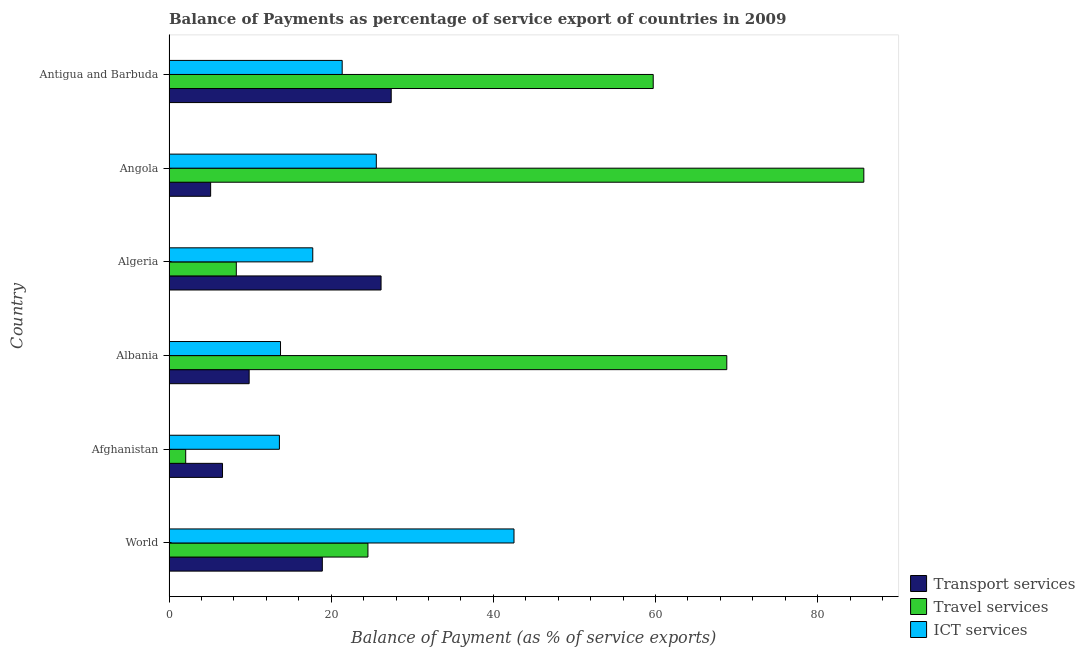How many different coloured bars are there?
Your answer should be very brief. 3. How many groups of bars are there?
Provide a succinct answer. 6. Are the number of bars per tick equal to the number of legend labels?
Give a very brief answer. Yes. Are the number of bars on each tick of the Y-axis equal?
Your answer should be very brief. Yes. How many bars are there on the 1st tick from the top?
Provide a succinct answer. 3. What is the balance of payment of travel services in World?
Provide a succinct answer. 24.54. Across all countries, what is the maximum balance of payment of transport services?
Your response must be concise. 27.41. Across all countries, what is the minimum balance of payment of transport services?
Offer a terse response. 5.14. In which country was the balance of payment of ict services maximum?
Ensure brevity in your answer.  World. In which country was the balance of payment of ict services minimum?
Give a very brief answer. Afghanistan. What is the total balance of payment of travel services in the graph?
Give a very brief answer. 249.12. What is the difference between the balance of payment of transport services in Albania and that in Algeria?
Give a very brief answer. -16.27. What is the difference between the balance of payment of transport services in Albania and the balance of payment of ict services in Antigua and Barbuda?
Offer a terse response. -11.47. What is the average balance of payment of ict services per country?
Keep it short and to the point. 22.43. What is the difference between the balance of payment of ict services and balance of payment of travel services in Angola?
Offer a terse response. -60.13. In how many countries, is the balance of payment of ict services greater than 60 %?
Provide a succinct answer. 0. What is the difference between the highest and the second highest balance of payment of transport services?
Your answer should be compact. 1.25. What is the difference between the highest and the lowest balance of payment of ict services?
Make the answer very short. 28.93. What does the 1st bar from the top in World represents?
Make the answer very short. ICT services. What does the 1st bar from the bottom in World represents?
Give a very brief answer. Transport services. Is it the case that in every country, the sum of the balance of payment of transport services and balance of payment of travel services is greater than the balance of payment of ict services?
Your response must be concise. No. How many bars are there?
Offer a terse response. 18. Are all the bars in the graph horizontal?
Provide a short and direct response. Yes. How many countries are there in the graph?
Keep it short and to the point. 6. What is the difference between two consecutive major ticks on the X-axis?
Make the answer very short. 20. Does the graph contain any zero values?
Ensure brevity in your answer.  No. Where does the legend appear in the graph?
Ensure brevity in your answer.  Bottom right. What is the title of the graph?
Offer a very short reply. Balance of Payments as percentage of service export of countries in 2009. Does "Unemployment benefits" appear as one of the legend labels in the graph?
Keep it short and to the point. No. What is the label or title of the X-axis?
Your response must be concise. Balance of Payment (as % of service exports). What is the Balance of Payment (as % of service exports) of Transport services in World?
Offer a terse response. 18.91. What is the Balance of Payment (as % of service exports) of Travel services in World?
Offer a very short reply. 24.54. What is the Balance of Payment (as % of service exports) in ICT services in World?
Make the answer very short. 42.55. What is the Balance of Payment (as % of service exports) in Transport services in Afghanistan?
Offer a terse response. 6.6. What is the Balance of Payment (as % of service exports) of Travel services in Afghanistan?
Make the answer very short. 2.06. What is the Balance of Payment (as % of service exports) in ICT services in Afghanistan?
Offer a terse response. 13.62. What is the Balance of Payment (as % of service exports) in Transport services in Albania?
Give a very brief answer. 9.89. What is the Balance of Payment (as % of service exports) of Travel services in Albania?
Give a very brief answer. 68.8. What is the Balance of Payment (as % of service exports) of ICT services in Albania?
Make the answer very short. 13.75. What is the Balance of Payment (as % of service exports) of Transport services in Algeria?
Offer a terse response. 26.15. What is the Balance of Payment (as % of service exports) in Travel services in Algeria?
Your response must be concise. 8.3. What is the Balance of Payment (as % of service exports) in ICT services in Algeria?
Give a very brief answer. 17.73. What is the Balance of Payment (as % of service exports) in Transport services in Angola?
Your answer should be compact. 5.14. What is the Balance of Payment (as % of service exports) of Travel services in Angola?
Your response must be concise. 85.7. What is the Balance of Payment (as % of service exports) of ICT services in Angola?
Your answer should be compact. 25.57. What is the Balance of Payment (as % of service exports) in Transport services in Antigua and Barbuda?
Offer a very short reply. 27.41. What is the Balance of Payment (as % of service exports) of Travel services in Antigua and Barbuda?
Your answer should be very brief. 59.72. What is the Balance of Payment (as % of service exports) of ICT services in Antigua and Barbuda?
Give a very brief answer. 21.36. Across all countries, what is the maximum Balance of Payment (as % of service exports) of Transport services?
Your response must be concise. 27.41. Across all countries, what is the maximum Balance of Payment (as % of service exports) of Travel services?
Offer a very short reply. 85.7. Across all countries, what is the maximum Balance of Payment (as % of service exports) of ICT services?
Your answer should be very brief. 42.55. Across all countries, what is the minimum Balance of Payment (as % of service exports) in Transport services?
Offer a terse response. 5.14. Across all countries, what is the minimum Balance of Payment (as % of service exports) of Travel services?
Make the answer very short. 2.06. Across all countries, what is the minimum Balance of Payment (as % of service exports) of ICT services?
Ensure brevity in your answer.  13.62. What is the total Balance of Payment (as % of service exports) of Transport services in the graph?
Offer a very short reply. 94.1. What is the total Balance of Payment (as % of service exports) in Travel services in the graph?
Make the answer very short. 249.12. What is the total Balance of Payment (as % of service exports) of ICT services in the graph?
Offer a very short reply. 134.58. What is the difference between the Balance of Payment (as % of service exports) of Transport services in World and that in Afghanistan?
Give a very brief answer. 12.31. What is the difference between the Balance of Payment (as % of service exports) in Travel services in World and that in Afghanistan?
Offer a terse response. 22.48. What is the difference between the Balance of Payment (as % of service exports) in ICT services in World and that in Afghanistan?
Provide a short and direct response. 28.93. What is the difference between the Balance of Payment (as % of service exports) of Transport services in World and that in Albania?
Give a very brief answer. 9.02. What is the difference between the Balance of Payment (as % of service exports) in Travel services in World and that in Albania?
Your response must be concise. -44.26. What is the difference between the Balance of Payment (as % of service exports) of ICT services in World and that in Albania?
Your answer should be very brief. 28.8. What is the difference between the Balance of Payment (as % of service exports) in Transport services in World and that in Algeria?
Keep it short and to the point. -7.24. What is the difference between the Balance of Payment (as % of service exports) of Travel services in World and that in Algeria?
Your answer should be very brief. 16.24. What is the difference between the Balance of Payment (as % of service exports) of ICT services in World and that in Algeria?
Ensure brevity in your answer.  24.82. What is the difference between the Balance of Payment (as % of service exports) in Transport services in World and that in Angola?
Keep it short and to the point. 13.78. What is the difference between the Balance of Payment (as % of service exports) in Travel services in World and that in Angola?
Your answer should be very brief. -61.16. What is the difference between the Balance of Payment (as % of service exports) in ICT services in World and that in Angola?
Provide a short and direct response. 16.98. What is the difference between the Balance of Payment (as % of service exports) of Transport services in World and that in Antigua and Barbuda?
Your answer should be compact. -8.5. What is the difference between the Balance of Payment (as % of service exports) of Travel services in World and that in Antigua and Barbuda?
Your answer should be very brief. -35.19. What is the difference between the Balance of Payment (as % of service exports) in ICT services in World and that in Antigua and Barbuda?
Provide a short and direct response. 21.19. What is the difference between the Balance of Payment (as % of service exports) of Transport services in Afghanistan and that in Albania?
Keep it short and to the point. -3.29. What is the difference between the Balance of Payment (as % of service exports) in Travel services in Afghanistan and that in Albania?
Provide a succinct answer. -66.74. What is the difference between the Balance of Payment (as % of service exports) of ICT services in Afghanistan and that in Albania?
Offer a very short reply. -0.14. What is the difference between the Balance of Payment (as % of service exports) of Transport services in Afghanistan and that in Algeria?
Make the answer very short. -19.55. What is the difference between the Balance of Payment (as % of service exports) of Travel services in Afghanistan and that in Algeria?
Make the answer very short. -6.24. What is the difference between the Balance of Payment (as % of service exports) of ICT services in Afghanistan and that in Algeria?
Offer a very short reply. -4.12. What is the difference between the Balance of Payment (as % of service exports) in Transport services in Afghanistan and that in Angola?
Provide a succinct answer. 1.47. What is the difference between the Balance of Payment (as % of service exports) in Travel services in Afghanistan and that in Angola?
Give a very brief answer. -83.64. What is the difference between the Balance of Payment (as % of service exports) in ICT services in Afghanistan and that in Angola?
Make the answer very short. -11.95. What is the difference between the Balance of Payment (as % of service exports) in Transport services in Afghanistan and that in Antigua and Barbuda?
Give a very brief answer. -20.81. What is the difference between the Balance of Payment (as % of service exports) in Travel services in Afghanistan and that in Antigua and Barbuda?
Your answer should be compact. -57.66. What is the difference between the Balance of Payment (as % of service exports) of ICT services in Afghanistan and that in Antigua and Barbuda?
Make the answer very short. -7.74. What is the difference between the Balance of Payment (as % of service exports) of Transport services in Albania and that in Algeria?
Your answer should be compact. -16.27. What is the difference between the Balance of Payment (as % of service exports) of Travel services in Albania and that in Algeria?
Keep it short and to the point. 60.5. What is the difference between the Balance of Payment (as % of service exports) of ICT services in Albania and that in Algeria?
Your answer should be very brief. -3.98. What is the difference between the Balance of Payment (as % of service exports) in Transport services in Albania and that in Angola?
Provide a succinct answer. 4.75. What is the difference between the Balance of Payment (as % of service exports) of Travel services in Albania and that in Angola?
Make the answer very short. -16.9. What is the difference between the Balance of Payment (as % of service exports) of ICT services in Albania and that in Angola?
Provide a short and direct response. -11.82. What is the difference between the Balance of Payment (as % of service exports) of Transport services in Albania and that in Antigua and Barbuda?
Offer a terse response. -17.52. What is the difference between the Balance of Payment (as % of service exports) of Travel services in Albania and that in Antigua and Barbuda?
Provide a succinct answer. 9.08. What is the difference between the Balance of Payment (as % of service exports) of ICT services in Albania and that in Antigua and Barbuda?
Your answer should be compact. -7.61. What is the difference between the Balance of Payment (as % of service exports) in Transport services in Algeria and that in Angola?
Your answer should be very brief. 21.02. What is the difference between the Balance of Payment (as % of service exports) of Travel services in Algeria and that in Angola?
Your response must be concise. -77.4. What is the difference between the Balance of Payment (as % of service exports) in ICT services in Algeria and that in Angola?
Provide a succinct answer. -7.84. What is the difference between the Balance of Payment (as % of service exports) of Transport services in Algeria and that in Antigua and Barbuda?
Provide a short and direct response. -1.25. What is the difference between the Balance of Payment (as % of service exports) in Travel services in Algeria and that in Antigua and Barbuda?
Make the answer very short. -51.42. What is the difference between the Balance of Payment (as % of service exports) in ICT services in Algeria and that in Antigua and Barbuda?
Your response must be concise. -3.63. What is the difference between the Balance of Payment (as % of service exports) in Transport services in Angola and that in Antigua and Barbuda?
Provide a short and direct response. -22.27. What is the difference between the Balance of Payment (as % of service exports) of Travel services in Angola and that in Antigua and Barbuda?
Your answer should be compact. 25.98. What is the difference between the Balance of Payment (as % of service exports) of ICT services in Angola and that in Antigua and Barbuda?
Keep it short and to the point. 4.21. What is the difference between the Balance of Payment (as % of service exports) of Transport services in World and the Balance of Payment (as % of service exports) of Travel services in Afghanistan?
Ensure brevity in your answer.  16.85. What is the difference between the Balance of Payment (as % of service exports) of Transport services in World and the Balance of Payment (as % of service exports) of ICT services in Afghanistan?
Offer a terse response. 5.29. What is the difference between the Balance of Payment (as % of service exports) of Travel services in World and the Balance of Payment (as % of service exports) of ICT services in Afghanistan?
Offer a very short reply. 10.92. What is the difference between the Balance of Payment (as % of service exports) of Transport services in World and the Balance of Payment (as % of service exports) of Travel services in Albania?
Offer a terse response. -49.89. What is the difference between the Balance of Payment (as % of service exports) of Transport services in World and the Balance of Payment (as % of service exports) of ICT services in Albania?
Ensure brevity in your answer.  5.16. What is the difference between the Balance of Payment (as % of service exports) of Travel services in World and the Balance of Payment (as % of service exports) of ICT services in Albania?
Provide a succinct answer. 10.78. What is the difference between the Balance of Payment (as % of service exports) in Transport services in World and the Balance of Payment (as % of service exports) in Travel services in Algeria?
Provide a succinct answer. 10.61. What is the difference between the Balance of Payment (as % of service exports) of Transport services in World and the Balance of Payment (as % of service exports) of ICT services in Algeria?
Ensure brevity in your answer.  1.18. What is the difference between the Balance of Payment (as % of service exports) of Travel services in World and the Balance of Payment (as % of service exports) of ICT services in Algeria?
Ensure brevity in your answer.  6.8. What is the difference between the Balance of Payment (as % of service exports) of Transport services in World and the Balance of Payment (as % of service exports) of Travel services in Angola?
Your answer should be compact. -66.79. What is the difference between the Balance of Payment (as % of service exports) of Transport services in World and the Balance of Payment (as % of service exports) of ICT services in Angola?
Ensure brevity in your answer.  -6.66. What is the difference between the Balance of Payment (as % of service exports) in Travel services in World and the Balance of Payment (as % of service exports) in ICT services in Angola?
Make the answer very short. -1.03. What is the difference between the Balance of Payment (as % of service exports) in Transport services in World and the Balance of Payment (as % of service exports) in Travel services in Antigua and Barbuda?
Offer a very short reply. -40.81. What is the difference between the Balance of Payment (as % of service exports) of Transport services in World and the Balance of Payment (as % of service exports) of ICT services in Antigua and Barbuda?
Make the answer very short. -2.45. What is the difference between the Balance of Payment (as % of service exports) of Travel services in World and the Balance of Payment (as % of service exports) of ICT services in Antigua and Barbuda?
Provide a succinct answer. 3.18. What is the difference between the Balance of Payment (as % of service exports) of Transport services in Afghanistan and the Balance of Payment (as % of service exports) of Travel services in Albania?
Provide a succinct answer. -62.2. What is the difference between the Balance of Payment (as % of service exports) of Transport services in Afghanistan and the Balance of Payment (as % of service exports) of ICT services in Albania?
Your answer should be compact. -7.15. What is the difference between the Balance of Payment (as % of service exports) of Travel services in Afghanistan and the Balance of Payment (as % of service exports) of ICT services in Albania?
Give a very brief answer. -11.69. What is the difference between the Balance of Payment (as % of service exports) in Transport services in Afghanistan and the Balance of Payment (as % of service exports) in Travel services in Algeria?
Ensure brevity in your answer.  -1.7. What is the difference between the Balance of Payment (as % of service exports) of Transport services in Afghanistan and the Balance of Payment (as % of service exports) of ICT services in Algeria?
Offer a very short reply. -11.13. What is the difference between the Balance of Payment (as % of service exports) in Travel services in Afghanistan and the Balance of Payment (as % of service exports) in ICT services in Algeria?
Give a very brief answer. -15.67. What is the difference between the Balance of Payment (as % of service exports) in Transport services in Afghanistan and the Balance of Payment (as % of service exports) in Travel services in Angola?
Ensure brevity in your answer.  -79.1. What is the difference between the Balance of Payment (as % of service exports) of Transport services in Afghanistan and the Balance of Payment (as % of service exports) of ICT services in Angola?
Give a very brief answer. -18.97. What is the difference between the Balance of Payment (as % of service exports) in Travel services in Afghanistan and the Balance of Payment (as % of service exports) in ICT services in Angola?
Offer a very short reply. -23.51. What is the difference between the Balance of Payment (as % of service exports) in Transport services in Afghanistan and the Balance of Payment (as % of service exports) in Travel services in Antigua and Barbuda?
Offer a very short reply. -53.12. What is the difference between the Balance of Payment (as % of service exports) in Transport services in Afghanistan and the Balance of Payment (as % of service exports) in ICT services in Antigua and Barbuda?
Your answer should be compact. -14.76. What is the difference between the Balance of Payment (as % of service exports) in Travel services in Afghanistan and the Balance of Payment (as % of service exports) in ICT services in Antigua and Barbuda?
Offer a very short reply. -19.3. What is the difference between the Balance of Payment (as % of service exports) of Transport services in Albania and the Balance of Payment (as % of service exports) of Travel services in Algeria?
Provide a succinct answer. 1.59. What is the difference between the Balance of Payment (as % of service exports) of Transport services in Albania and the Balance of Payment (as % of service exports) of ICT services in Algeria?
Keep it short and to the point. -7.85. What is the difference between the Balance of Payment (as % of service exports) of Travel services in Albania and the Balance of Payment (as % of service exports) of ICT services in Algeria?
Ensure brevity in your answer.  51.07. What is the difference between the Balance of Payment (as % of service exports) in Transport services in Albania and the Balance of Payment (as % of service exports) in Travel services in Angola?
Make the answer very short. -75.81. What is the difference between the Balance of Payment (as % of service exports) in Transport services in Albania and the Balance of Payment (as % of service exports) in ICT services in Angola?
Provide a short and direct response. -15.68. What is the difference between the Balance of Payment (as % of service exports) in Travel services in Albania and the Balance of Payment (as % of service exports) in ICT services in Angola?
Your answer should be very brief. 43.23. What is the difference between the Balance of Payment (as % of service exports) of Transport services in Albania and the Balance of Payment (as % of service exports) of Travel services in Antigua and Barbuda?
Your answer should be very brief. -49.84. What is the difference between the Balance of Payment (as % of service exports) in Transport services in Albania and the Balance of Payment (as % of service exports) in ICT services in Antigua and Barbuda?
Your response must be concise. -11.47. What is the difference between the Balance of Payment (as % of service exports) of Travel services in Albania and the Balance of Payment (as % of service exports) of ICT services in Antigua and Barbuda?
Offer a very short reply. 47.44. What is the difference between the Balance of Payment (as % of service exports) in Transport services in Algeria and the Balance of Payment (as % of service exports) in Travel services in Angola?
Give a very brief answer. -59.54. What is the difference between the Balance of Payment (as % of service exports) in Transport services in Algeria and the Balance of Payment (as % of service exports) in ICT services in Angola?
Offer a terse response. 0.58. What is the difference between the Balance of Payment (as % of service exports) of Travel services in Algeria and the Balance of Payment (as % of service exports) of ICT services in Angola?
Ensure brevity in your answer.  -17.27. What is the difference between the Balance of Payment (as % of service exports) in Transport services in Algeria and the Balance of Payment (as % of service exports) in Travel services in Antigua and Barbuda?
Provide a succinct answer. -33.57. What is the difference between the Balance of Payment (as % of service exports) of Transport services in Algeria and the Balance of Payment (as % of service exports) of ICT services in Antigua and Barbuda?
Offer a very short reply. 4.79. What is the difference between the Balance of Payment (as % of service exports) in Travel services in Algeria and the Balance of Payment (as % of service exports) in ICT services in Antigua and Barbuda?
Offer a very short reply. -13.06. What is the difference between the Balance of Payment (as % of service exports) of Transport services in Angola and the Balance of Payment (as % of service exports) of Travel services in Antigua and Barbuda?
Ensure brevity in your answer.  -54.59. What is the difference between the Balance of Payment (as % of service exports) in Transport services in Angola and the Balance of Payment (as % of service exports) in ICT services in Antigua and Barbuda?
Offer a terse response. -16.23. What is the difference between the Balance of Payment (as % of service exports) in Travel services in Angola and the Balance of Payment (as % of service exports) in ICT services in Antigua and Barbuda?
Give a very brief answer. 64.34. What is the average Balance of Payment (as % of service exports) of Transport services per country?
Keep it short and to the point. 15.68. What is the average Balance of Payment (as % of service exports) of Travel services per country?
Ensure brevity in your answer.  41.52. What is the average Balance of Payment (as % of service exports) in ICT services per country?
Give a very brief answer. 22.43. What is the difference between the Balance of Payment (as % of service exports) in Transport services and Balance of Payment (as % of service exports) in Travel services in World?
Offer a terse response. -5.63. What is the difference between the Balance of Payment (as % of service exports) in Transport services and Balance of Payment (as % of service exports) in ICT services in World?
Provide a short and direct response. -23.64. What is the difference between the Balance of Payment (as % of service exports) in Travel services and Balance of Payment (as % of service exports) in ICT services in World?
Offer a terse response. -18.01. What is the difference between the Balance of Payment (as % of service exports) of Transport services and Balance of Payment (as % of service exports) of Travel services in Afghanistan?
Your response must be concise. 4.54. What is the difference between the Balance of Payment (as % of service exports) in Transport services and Balance of Payment (as % of service exports) in ICT services in Afghanistan?
Ensure brevity in your answer.  -7.02. What is the difference between the Balance of Payment (as % of service exports) in Travel services and Balance of Payment (as % of service exports) in ICT services in Afghanistan?
Provide a succinct answer. -11.56. What is the difference between the Balance of Payment (as % of service exports) in Transport services and Balance of Payment (as % of service exports) in Travel services in Albania?
Offer a very short reply. -58.91. What is the difference between the Balance of Payment (as % of service exports) in Transport services and Balance of Payment (as % of service exports) in ICT services in Albania?
Your answer should be very brief. -3.87. What is the difference between the Balance of Payment (as % of service exports) of Travel services and Balance of Payment (as % of service exports) of ICT services in Albania?
Provide a short and direct response. 55.04. What is the difference between the Balance of Payment (as % of service exports) of Transport services and Balance of Payment (as % of service exports) of Travel services in Algeria?
Your answer should be compact. 17.85. What is the difference between the Balance of Payment (as % of service exports) of Transport services and Balance of Payment (as % of service exports) of ICT services in Algeria?
Your answer should be very brief. 8.42. What is the difference between the Balance of Payment (as % of service exports) in Travel services and Balance of Payment (as % of service exports) in ICT services in Algeria?
Make the answer very short. -9.43. What is the difference between the Balance of Payment (as % of service exports) of Transport services and Balance of Payment (as % of service exports) of Travel services in Angola?
Your answer should be compact. -80.56. What is the difference between the Balance of Payment (as % of service exports) of Transport services and Balance of Payment (as % of service exports) of ICT services in Angola?
Your answer should be compact. -20.43. What is the difference between the Balance of Payment (as % of service exports) of Travel services and Balance of Payment (as % of service exports) of ICT services in Angola?
Ensure brevity in your answer.  60.13. What is the difference between the Balance of Payment (as % of service exports) of Transport services and Balance of Payment (as % of service exports) of Travel services in Antigua and Barbuda?
Ensure brevity in your answer.  -32.32. What is the difference between the Balance of Payment (as % of service exports) of Transport services and Balance of Payment (as % of service exports) of ICT services in Antigua and Barbuda?
Provide a succinct answer. 6.05. What is the difference between the Balance of Payment (as % of service exports) of Travel services and Balance of Payment (as % of service exports) of ICT services in Antigua and Barbuda?
Make the answer very short. 38.36. What is the ratio of the Balance of Payment (as % of service exports) in Transport services in World to that in Afghanistan?
Provide a succinct answer. 2.87. What is the ratio of the Balance of Payment (as % of service exports) in Travel services in World to that in Afghanistan?
Offer a terse response. 11.9. What is the ratio of the Balance of Payment (as % of service exports) of ICT services in World to that in Afghanistan?
Your response must be concise. 3.12. What is the ratio of the Balance of Payment (as % of service exports) of Transport services in World to that in Albania?
Make the answer very short. 1.91. What is the ratio of the Balance of Payment (as % of service exports) of Travel services in World to that in Albania?
Keep it short and to the point. 0.36. What is the ratio of the Balance of Payment (as % of service exports) of ICT services in World to that in Albania?
Provide a succinct answer. 3.09. What is the ratio of the Balance of Payment (as % of service exports) of Transport services in World to that in Algeria?
Provide a succinct answer. 0.72. What is the ratio of the Balance of Payment (as % of service exports) in Travel services in World to that in Algeria?
Your answer should be compact. 2.96. What is the ratio of the Balance of Payment (as % of service exports) in ICT services in World to that in Algeria?
Provide a short and direct response. 2.4. What is the ratio of the Balance of Payment (as % of service exports) of Transport services in World to that in Angola?
Your response must be concise. 3.68. What is the ratio of the Balance of Payment (as % of service exports) of Travel services in World to that in Angola?
Ensure brevity in your answer.  0.29. What is the ratio of the Balance of Payment (as % of service exports) of ICT services in World to that in Angola?
Keep it short and to the point. 1.66. What is the ratio of the Balance of Payment (as % of service exports) in Transport services in World to that in Antigua and Barbuda?
Give a very brief answer. 0.69. What is the ratio of the Balance of Payment (as % of service exports) in Travel services in World to that in Antigua and Barbuda?
Provide a short and direct response. 0.41. What is the ratio of the Balance of Payment (as % of service exports) of ICT services in World to that in Antigua and Barbuda?
Provide a succinct answer. 1.99. What is the ratio of the Balance of Payment (as % of service exports) of Transport services in Afghanistan to that in Albania?
Ensure brevity in your answer.  0.67. What is the ratio of the Balance of Payment (as % of service exports) in Travel services in Afghanistan to that in Albania?
Ensure brevity in your answer.  0.03. What is the ratio of the Balance of Payment (as % of service exports) of Transport services in Afghanistan to that in Algeria?
Give a very brief answer. 0.25. What is the ratio of the Balance of Payment (as % of service exports) in Travel services in Afghanistan to that in Algeria?
Provide a short and direct response. 0.25. What is the ratio of the Balance of Payment (as % of service exports) in ICT services in Afghanistan to that in Algeria?
Provide a succinct answer. 0.77. What is the ratio of the Balance of Payment (as % of service exports) in Transport services in Afghanistan to that in Angola?
Give a very brief answer. 1.29. What is the ratio of the Balance of Payment (as % of service exports) in Travel services in Afghanistan to that in Angola?
Your answer should be very brief. 0.02. What is the ratio of the Balance of Payment (as % of service exports) in ICT services in Afghanistan to that in Angola?
Provide a short and direct response. 0.53. What is the ratio of the Balance of Payment (as % of service exports) of Transport services in Afghanistan to that in Antigua and Barbuda?
Ensure brevity in your answer.  0.24. What is the ratio of the Balance of Payment (as % of service exports) in Travel services in Afghanistan to that in Antigua and Barbuda?
Provide a succinct answer. 0.03. What is the ratio of the Balance of Payment (as % of service exports) of ICT services in Afghanistan to that in Antigua and Barbuda?
Your response must be concise. 0.64. What is the ratio of the Balance of Payment (as % of service exports) of Transport services in Albania to that in Algeria?
Your answer should be compact. 0.38. What is the ratio of the Balance of Payment (as % of service exports) of Travel services in Albania to that in Algeria?
Keep it short and to the point. 8.29. What is the ratio of the Balance of Payment (as % of service exports) of ICT services in Albania to that in Algeria?
Your response must be concise. 0.78. What is the ratio of the Balance of Payment (as % of service exports) in Transport services in Albania to that in Angola?
Provide a short and direct response. 1.93. What is the ratio of the Balance of Payment (as % of service exports) in Travel services in Albania to that in Angola?
Your response must be concise. 0.8. What is the ratio of the Balance of Payment (as % of service exports) in ICT services in Albania to that in Angola?
Keep it short and to the point. 0.54. What is the ratio of the Balance of Payment (as % of service exports) in Transport services in Albania to that in Antigua and Barbuda?
Provide a short and direct response. 0.36. What is the ratio of the Balance of Payment (as % of service exports) in Travel services in Albania to that in Antigua and Barbuda?
Offer a terse response. 1.15. What is the ratio of the Balance of Payment (as % of service exports) of ICT services in Albania to that in Antigua and Barbuda?
Your response must be concise. 0.64. What is the ratio of the Balance of Payment (as % of service exports) in Transport services in Algeria to that in Angola?
Give a very brief answer. 5.09. What is the ratio of the Balance of Payment (as % of service exports) of Travel services in Algeria to that in Angola?
Provide a short and direct response. 0.1. What is the ratio of the Balance of Payment (as % of service exports) of ICT services in Algeria to that in Angola?
Your answer should be very brief. 0.69. What is the ratio of the Balance of Payment (as % of service exports) of Transport services in Algeria to that in Antigua and Barbuda?
Your response must be concise. 0.95. What is the ratio of the Balance of Payment (as % of service exports) in Travel services in Algeria to that in Antigua and Barbuda?
Make the answer very short. 0.14. What is the ratio of the Balance of Payment (as % of service exports) in ICT services in Algeria to that in Antigua and Barbuda?
Ensure brevity in your answer.  0.83. What is the ratio of the Balance of Payment (as % of service exports) in Transport services in Angola to that in Antigua and Barbuda?
Ensure brevity in your answer.  0.19. What is the ratio of the Balance of Payment (as % of service exports) in Travel services in Angola to that in Antigua and Barbuda?
Keep it short and to the point. 1.43. What is the ratio of the Balance of Payment (as % of service exports) of ICT services in Angola to that in Antigua and Barbuda?
Offer a very short reply. 1.2. What is the difference between the highest and the second highest Balance of Payment (as % of service exports) in Transport services?
Your response must be concise. 1.25. What is the difference between the highest and the second highest Balance of Payment (as % of service exports) in Travel services?
Your answer should be compact. 16.9. What is the difference between the highest and the second highest Balance of Payment (as % of service exports) in ICT services?
Your answer should be compact. 16.98. What is the difference between the highest and the lowest Balance of Payment (as % of service exports) of Transport services?
Your response must be concise. 22.27. What is the difference between the highest and the lowest Balance of Payment (as % of service exports) in Travel services?
Your answer should be very brief. 83.64. What is the difference between the highest and the lowest Balance of Payment (as % of service exports) of ICT services?
Offer a very short reply. 28.93. 